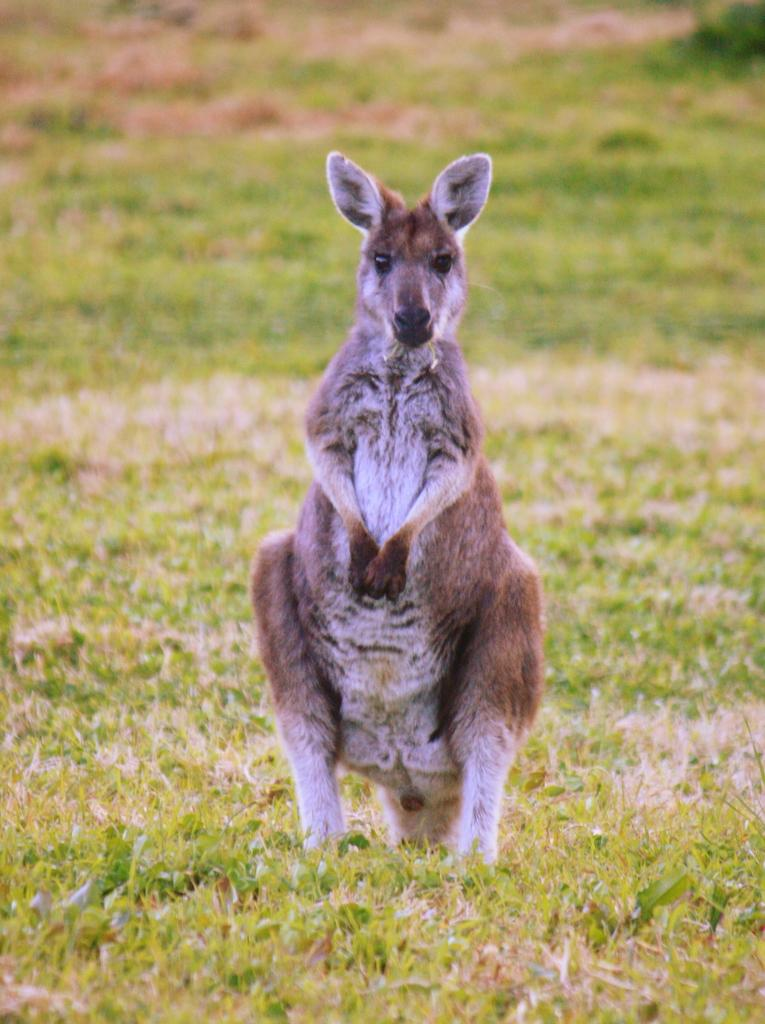What animal is the main subject of the picture? There is a kangaroo in the picture. What is the kangaroo doing in the picture? The kangaroo is standing. What type of terrain is visible at the bottom of the picture? There is grass at the bottom of the picture. What other element can be seen in the picture besides the kangaroo and grass? There is mud in the picture. What color is the bucket in the picture? There is no bucket present in the picture. How many stomachs does the kangaroo have in the picture? The number of stomachs a kangaroo has cannot be determined from the picture alone, as it is a biological characteristic rather than a visible feature. 